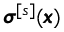Convert formula to latex. <formula><loc_0><loc_0><loc_500><loc_500>{ \pm b \sigma } ^ { [ s ] } ( { \pm b x } )</formula> 